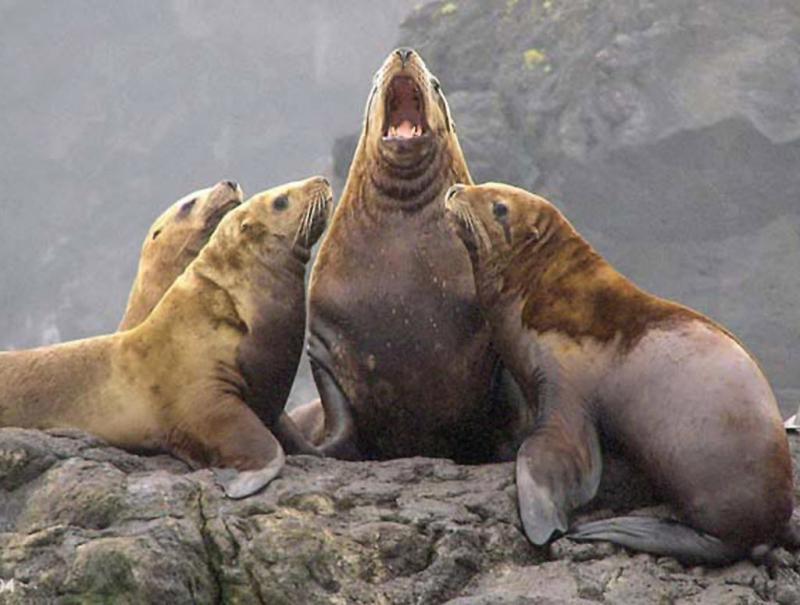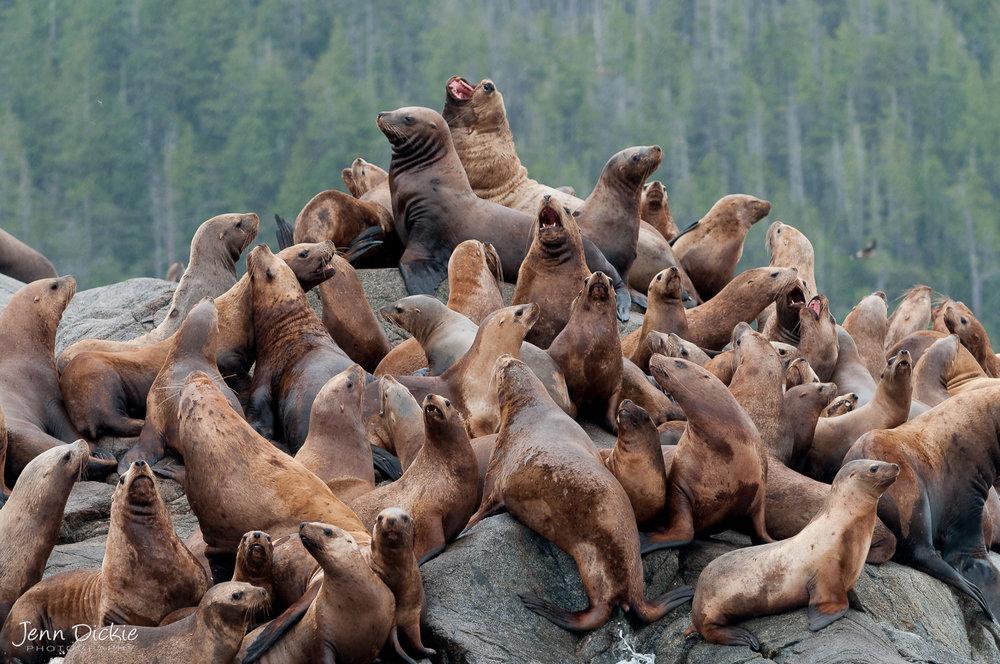The first image is the image on the left, the second image is the image on the right. Examine the images to the left and right. Is the description "One of the seals has his mouth open in the left image." accurate? Answer yes or no. Yes. The first image is the image on the left, the second image is the image on the right. Evaluate the accuracy of this statement regarding the images: "At least one seal is showing its teeth.". Is it true? Answer yes or no. Yes. 